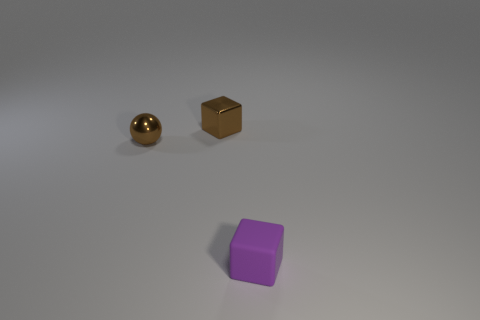There is a small brown object that is in front of the cube that is behind the tiny purple rubber cube; what shape is it?
Give a very brief answer. Sphere. Is the size of the metallic thing right of the brown metallic sphere the same as the brown metal object that is left of the small brown shiny cube?
Your response must be concise. Yes. Is there a large red cylinder made of the same material as the tiny brown sphere?
Your answer should be very brief. No. There is a metallic block that is the same color as the tiny ball; what size is it?
Offer a terse response. Small. There is a thing right of the brown thing that is on the right side of the ball; are there any brown balls in front of it?
Give a very brief answer. No. There is a metal cube; are there any tiny things in front of it?
Keep it short and to the point. Yes. What number of tiny brown metal spheres are left of the object that is behind the tiny metallic sphere?
Your answer should be very brief. 1. Do the purple matte block and the cube on the left side of the small purple thing have the same size?
Keep it short and to the point. Yes. Are there any metal things of the same color as the rubber cube?
Your response must be concise. No. The cube that is the same material as the ball is what size?
Your answer should be compact. Small. 